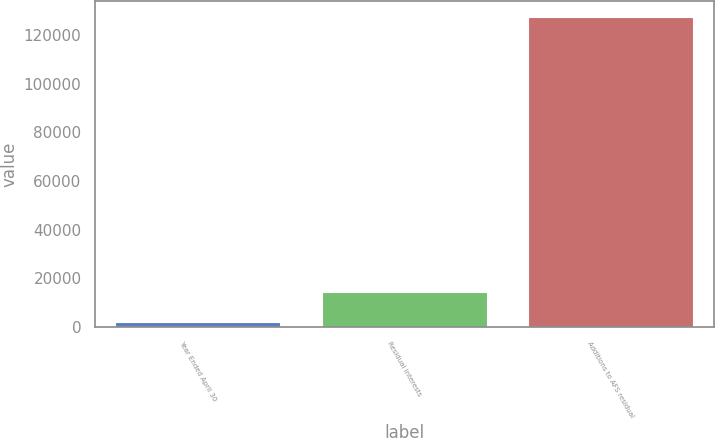<chart> <loc_0><loc_0><loc_500><loc_500><bar_chart><fcel>Year Ended April 30<fcel>Residual interests<fcel>Additions to AFS residual<nl><fcel>2007<fcel>14564.3<fcel>127580<nl></chart> 